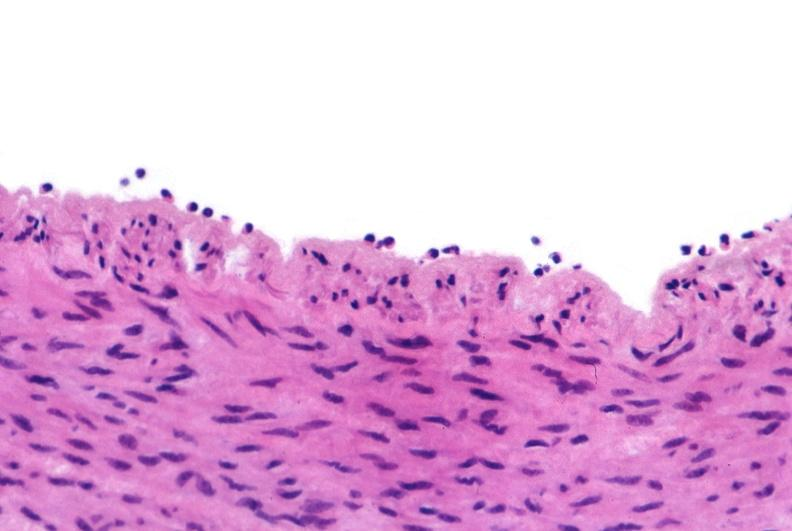what is present?
Answer the question using a single word or phrase. Vasculature 